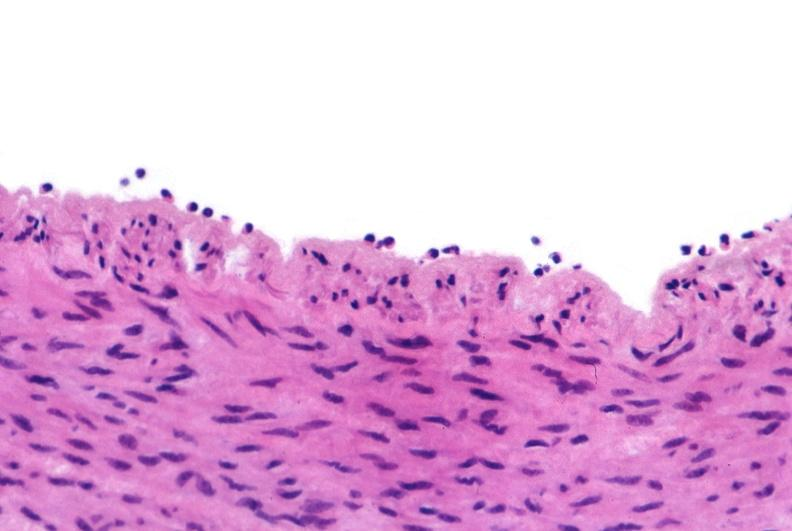what is present?
Answer the question using a single word or phrase. Vasculature 